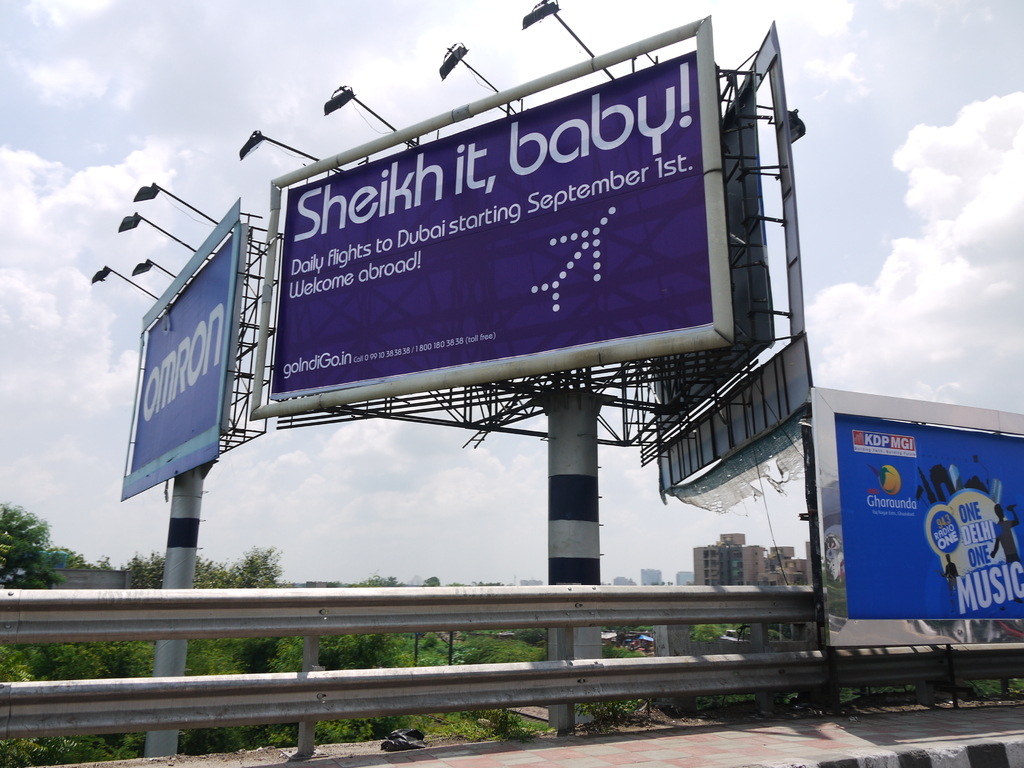Are there any other ads visible on the billboard, and what do they promote? Yes, alongside the main Dubai flights advertisement, there's another smaller billboard promoting 'ONE Delhi ONE Music', which appears to be a cultural or entertainment event, highlighting its reach and popularity within the local community. 